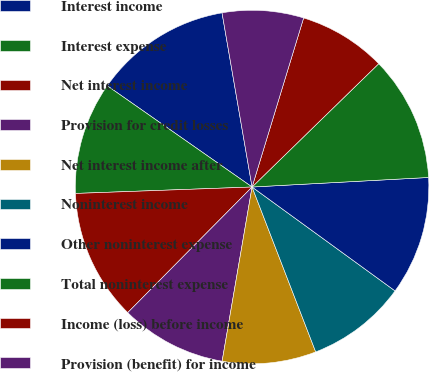<chart> <loc_0><loc_0><loc_500><loc_500><pie_chart><fcel>Interest income<fcel>Interest expense<fcel>Net interest income<fcel>Provision for credit losses<fcel>Net interest income after<fcel>Noninterest income<fcel>Other noninterest expense<fcel>Total noninterest expense<fcel>Income (loss) before income<fcel>Provision (benefit) for income<nl><fcel>12.57%<fcel>10.29%<fcel>12.0%<fcel>9.71%<fcel>8.57%<fcel>9.14%<fcel>10.86%<fcel>11.43%<fcel>8.0%<fcel>7.43%<nl></chart> 